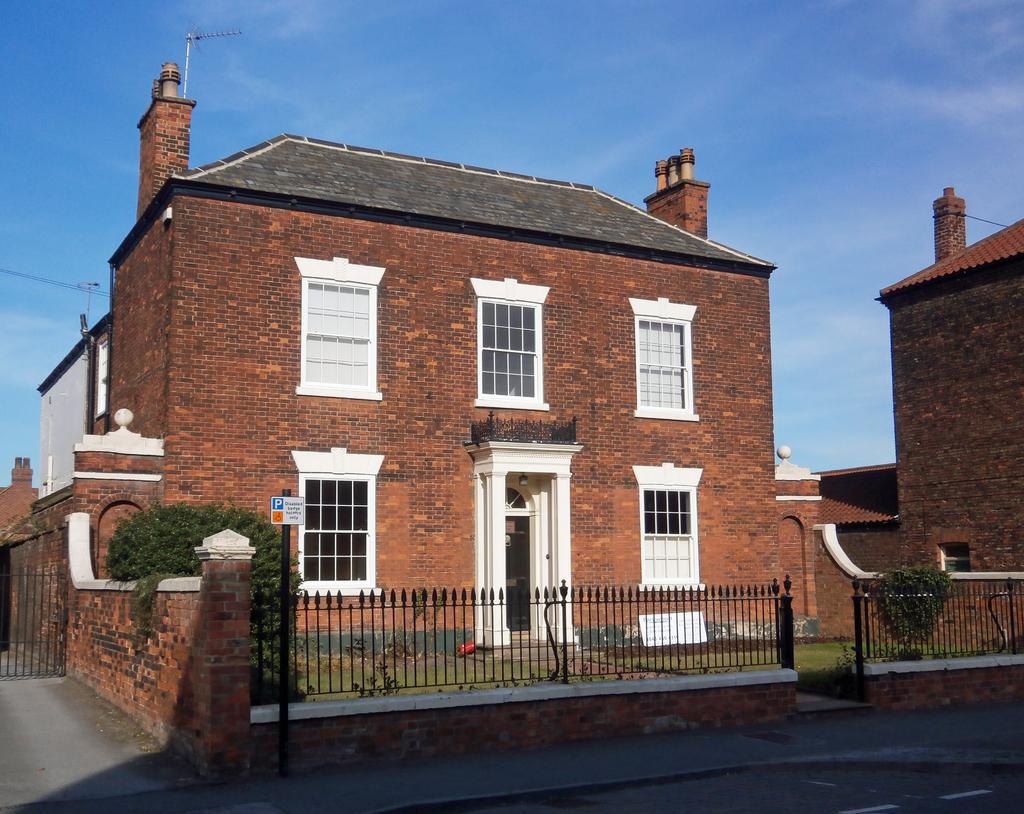Could you give a brief overview of what you see in this image? In this image there is the sky, there is a house, there is a house truncated towards the right of the image, there are plants, there is grass, there is road, there is a parking board attached to a pole, there are grills, there is a gate truncated towards the left of the image. 